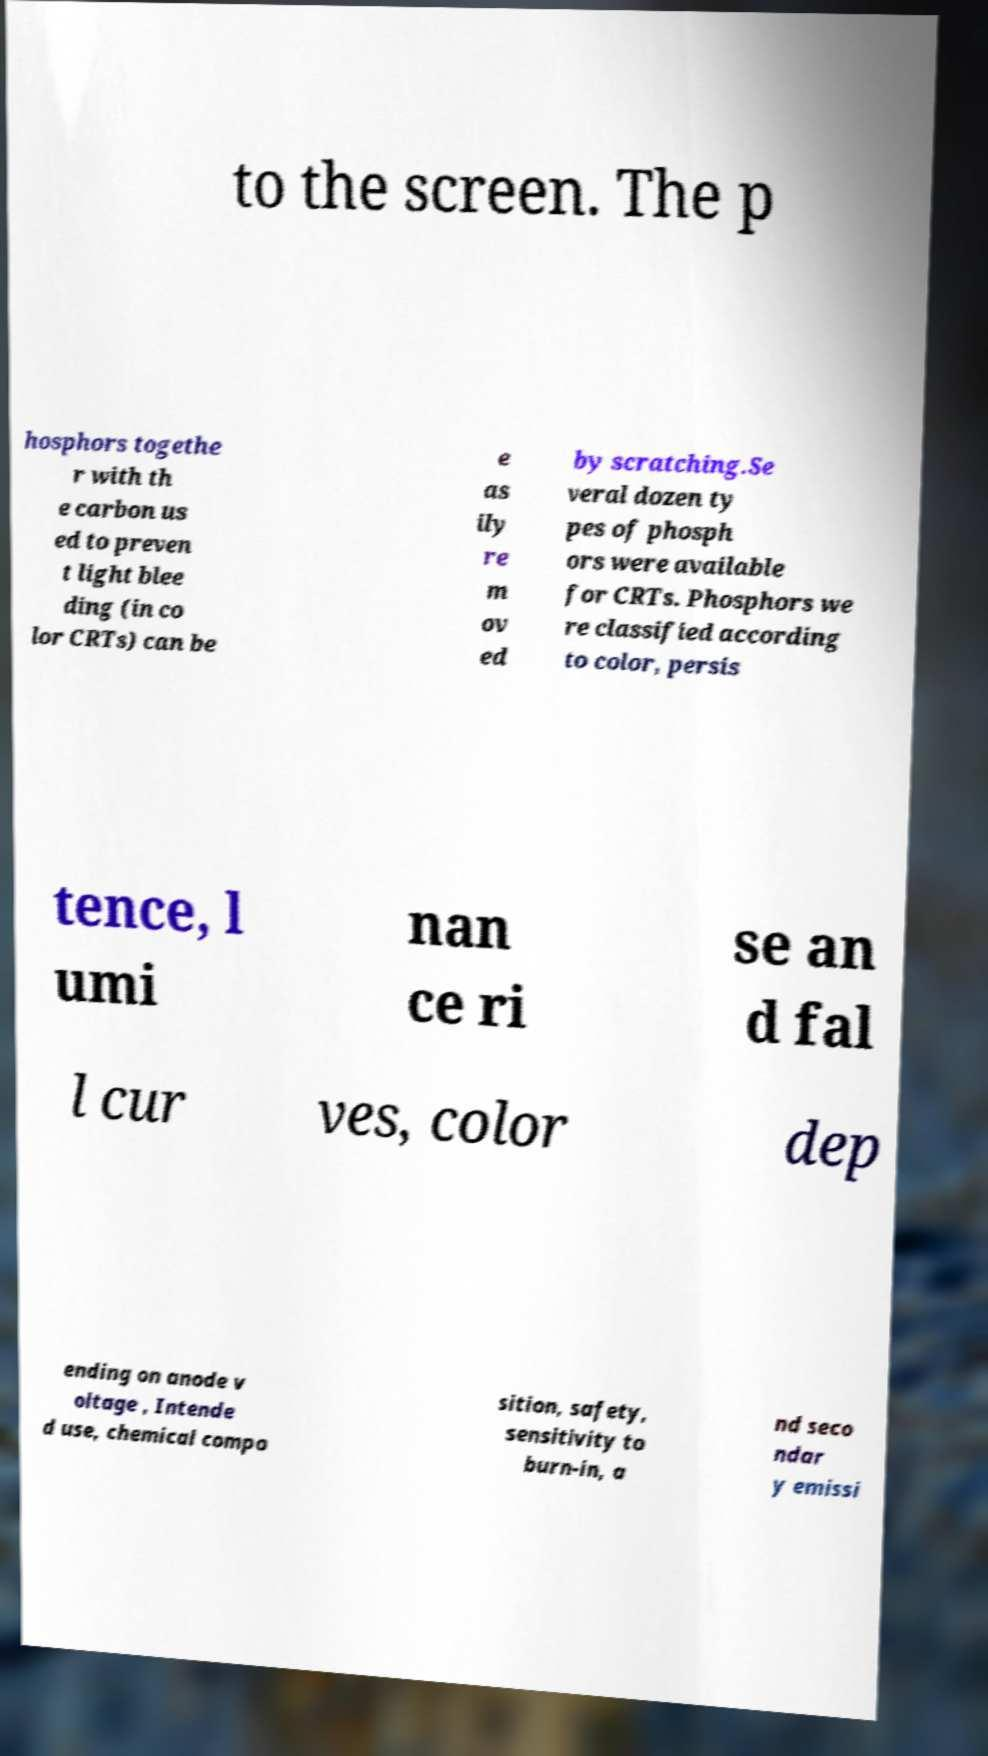What messages or text are displayed in this image? I need them in a readable, typed format. to the screen. The p hosphors togethe r with th e carbon us ed to preven t light blee ding (in co lor CRTs) can be e as ily re m ov ed by scratching.Se veral dozen ty pes of phosph ors were available for CRTs. Phosphors we re classified according to color, persis tence, l umi nan ce ri se an d fal l cur ves, color dep ending on anode v oltage , Intende d use, chemical compo sition, safety, sensitivity to burn-in, a nd seco ndar y emissi 